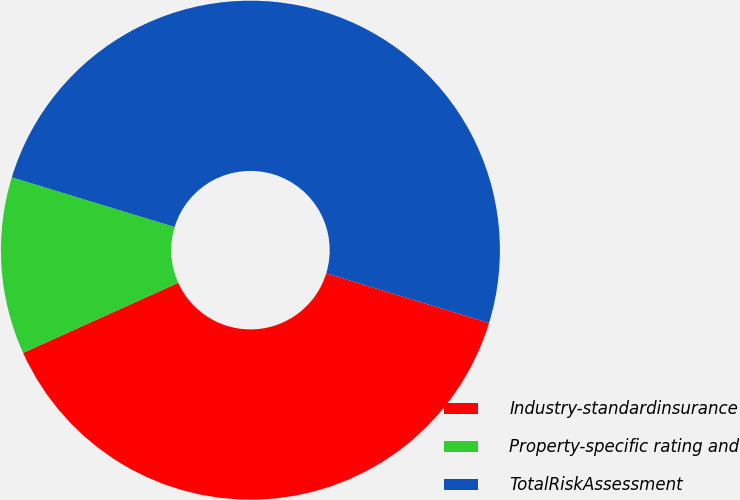Convert chart to OTSL. <chart><loc_0><loc_0><loc_500><loc_500><pie_chart><fcel>Industry-standardinsurance<fcel>Property-specific rating and<fcel>TotalRiskAssessment<nl><fcel>38.53%<fcel>11.47%<fcel>50.0%<nl></chart> 